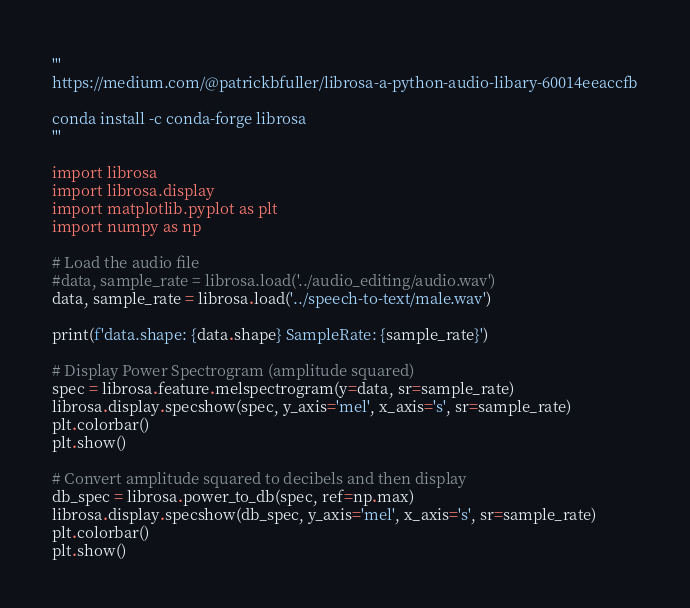<code> <loc_0><loc_0><loc_500><loc_500><_Python_>'''
https://medium.com/@patrickbfuller/librosa-a-python-audio-libary-60014eeaccfb

conda install -c conda-forge librosa
'''

import librosa
import librosa.display
import matplotlib.pyplot as plt
import numpy as np

# Load the audio file
#data, sample_rate = librosa.load('../audio_editing/audio.wav')
data, sample_rate = librosa.load('../speech-to-text/male.wav')

print(f'data.shape: {data.shape} SampleRate: {sample_rate}')

# Display Power Spectrogram (amplitude squared)
spec = librosa.feature.melspectrogram(y=data, sr=sample_rate)
librosa.display.specshow(spec, y_axis='mel', x_axis='s', sr=sample_rate)
plt.colorbar()
plt.show()

# Convert amplitude squared to decibels and then display
db_spec = librosa.power_to_db(spec, ref=np.max)
librosa.display.specshow(db_spec, y_axis='mel', x_axis='s', sr=sample_rate)
plt.colorbar()
plt.show()
</code> 